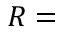Convert formula to latex. <formula><loc_0><loc_0><loc_500><loc_500>R =</formula> 